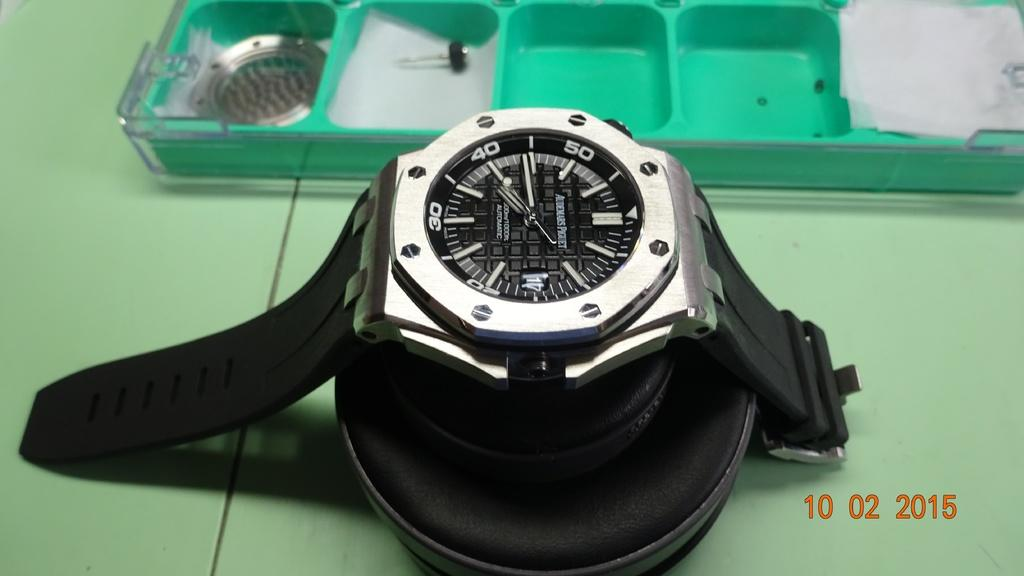<image>
Summarize the visual content of the image. A watch is displayed on a green table and shows a time of 7:44. 